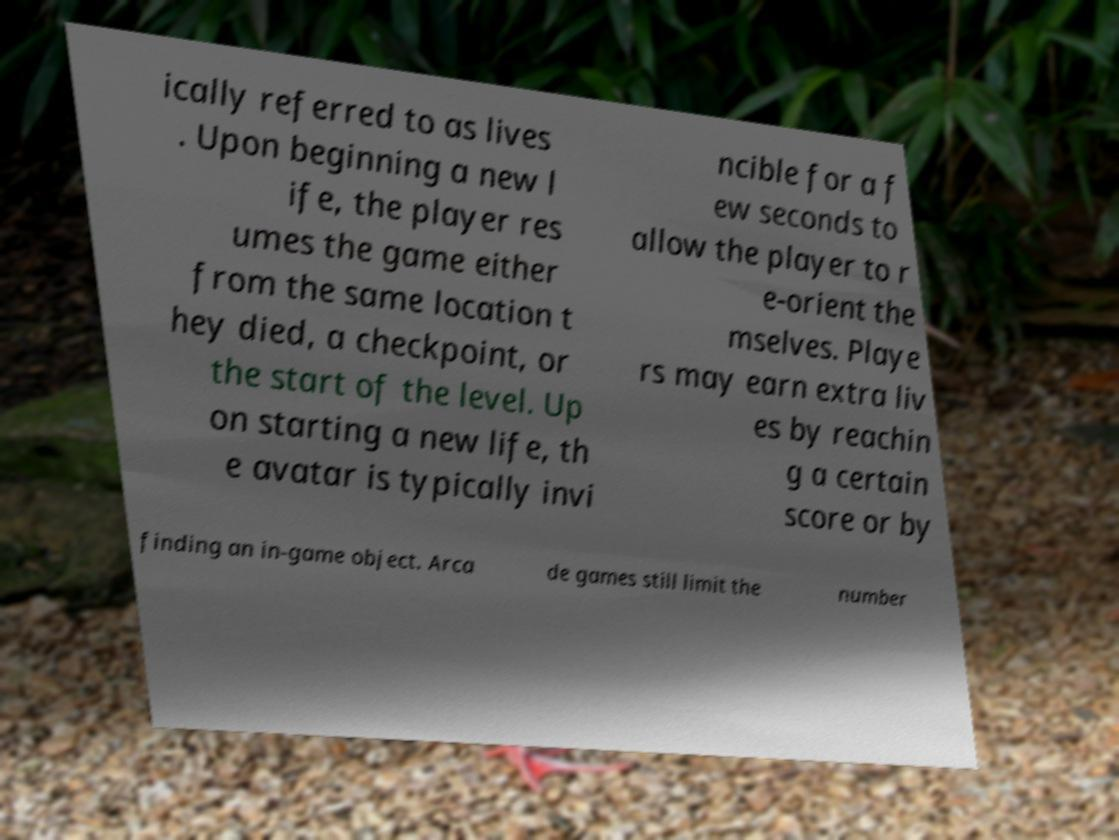There's text embedded in this image that I need extracted. Can you transcribe it verbatim? ically referred to as lives . Upon beginning a new l ife, the player res umes the game either from the same location t hey died, a checkpoint, or the start of the level. Up on starting a new life, th e avatar is typically invi ncible for a f ew seconds to allow the player to r e-orient the mselves. Playe rs may earn extra liv es by reachin g a certain score or by finding an in-game object. Arca de games still limit the number 